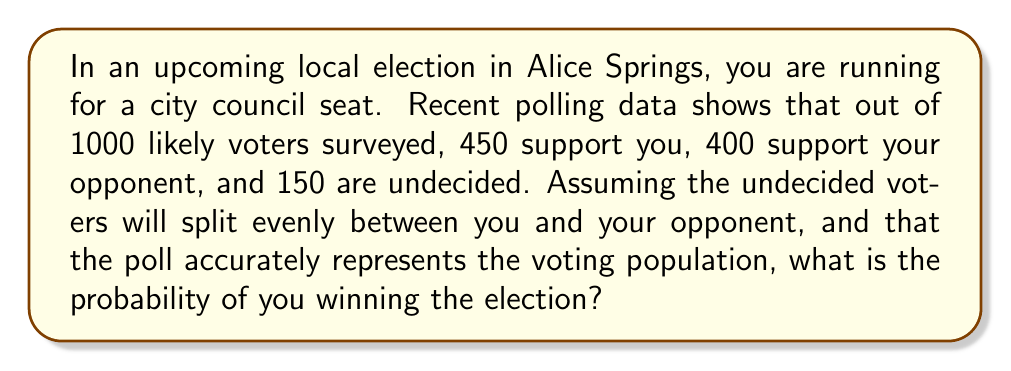Can you solve this math problem? Let's approach this step-by-step:

1) First, we need to calculate the total number of votes you and your opponent are likely to receive:

   Your initial votes: 450
   Your opponent's initial votes: 400
   Undecided votes: 150

2) The undecided votes will split evenly:
   $150 \div 2 = 75$ additional votes for each candidate

3) Total votes for each candidate:
   You: $450 + 75 = 525$
   Opponent: $400 + 75 = 475$

4) Total number of voters:
   $525 + 475 = 1000$

5) To win, you need more than half of the total votes:
   $1000 \div 2 = 500$

6) The probability of winning is the number of favorable outcomes divided by the total number of possible outcomes. In this case, it's the number of votes above 500 divided by the total number of votes:

   $P(\text{winning}) = \frac{525 - 500}{1000} = \frac{25}{1000} = 0.025$

7) Convert to a percentage:
   $0.025 \times 100\% = 2.5\%$

Therefore, based on this polling data, you have a 2.5% lead, which translates to a 52.5% chance of winning the election (assuming the poll is perfectly accurate and representative).
Answer: 52.5% 